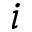Convert formula to latex. <formula><loc_0><loc_0><loc_500><loc_500>i</formula> 